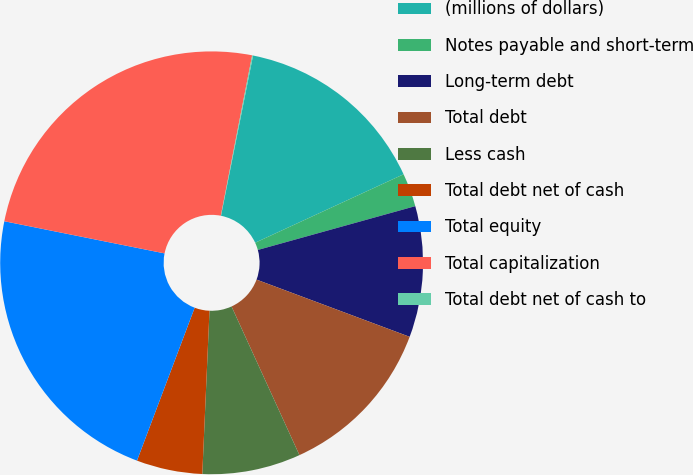Convert chart. <chart><loc_0><loc_0><loc_500><loc_500><pie_chart><fcel>(millions of dollars)<fcel>Notes payable and short-term<fcel>Long-term debt<fcel>Total debt<fcel>Less cash<fcel>Total debt net of cash<fcel>Total equity<fcel>Total capitalization<fcel>Total debt net of cash to<nl><fcel>14.98%<fcel>2.56%<fcel>10.01%<fcel>12.49%<fcel>7.52%<fcel>5.04%<fcel>22.41%<fcel>24.92%<fcel>0.07%<nl></chart> 